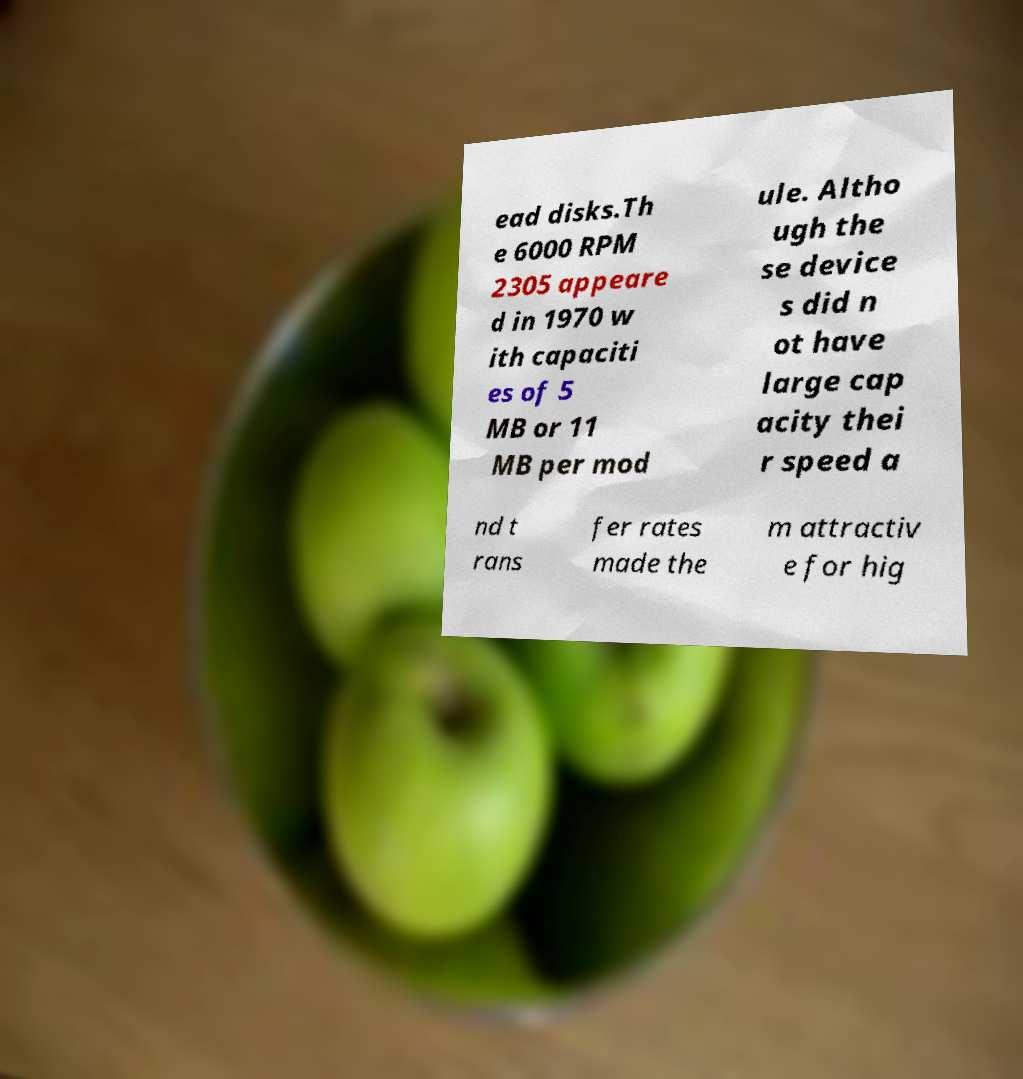Could you assist in decoding the text presented in this image and type it out clearly? ead disks.Th e 6000 RPM 2305 appeare d in 1970 w ith capaciti es of 5 MB or 11 MB per mod ule. Altho ugh the se device s did n ot have large cap acity thei r speed a nd t rans fer rates made the m attractiv e for hig 